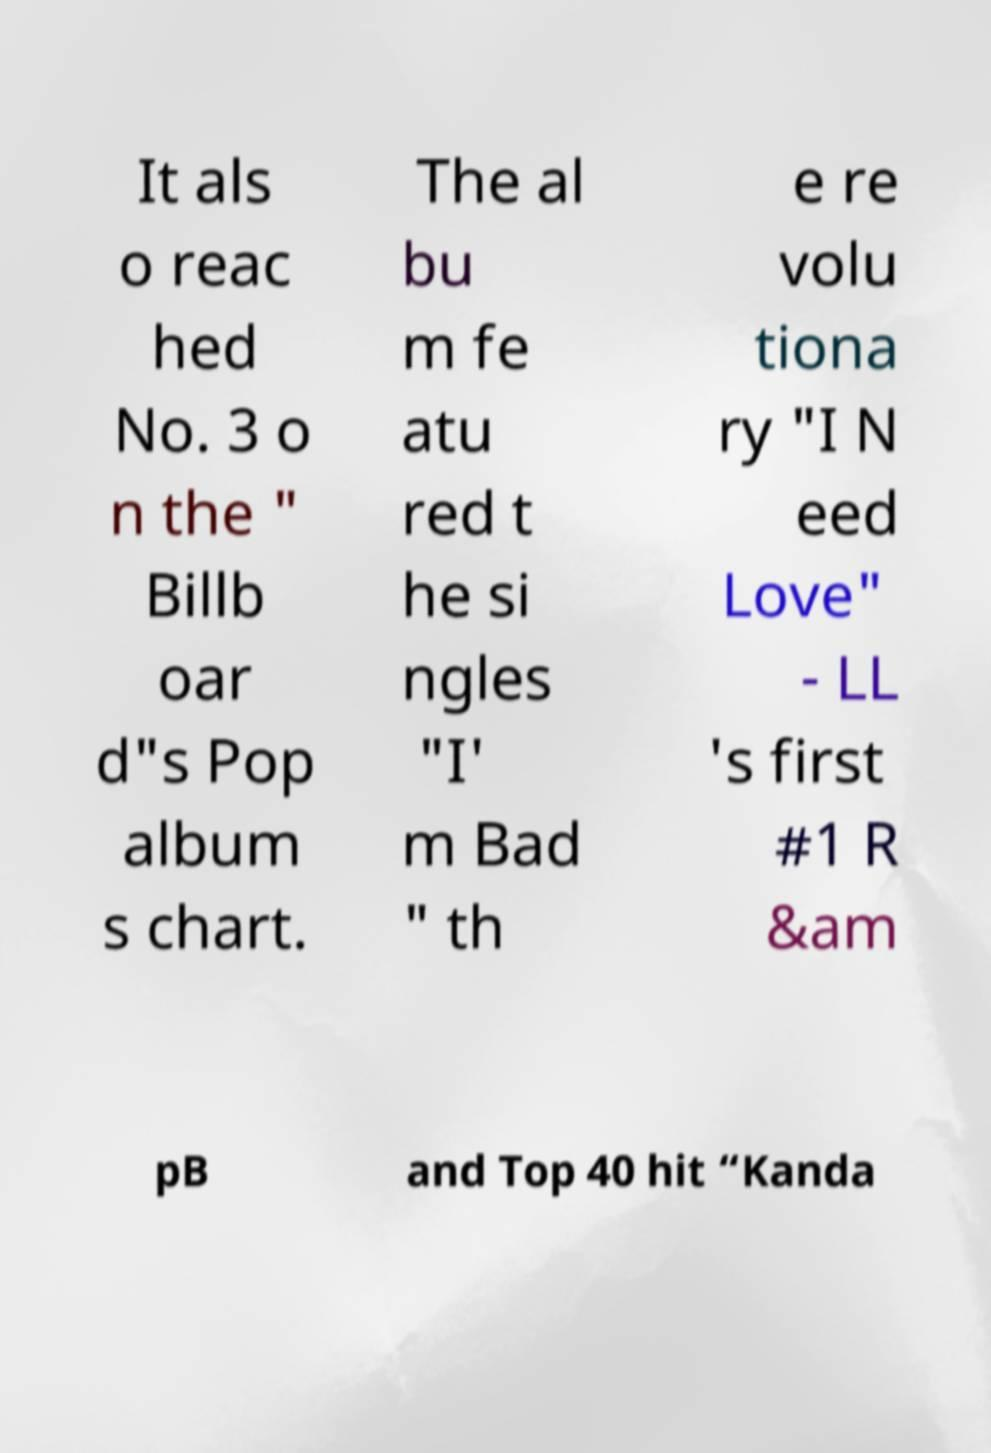Please identify and transcribe the text found in this image. It als o reac hed No. 3 o n the " Billb oar d"s Pop album s chart. The al bu m fe atu red t he si ngles "I' m Bad " th e re volu tiona ry "I N eed Love" - LL 's first #1 R &am pB and Top 40 hit “Kanda 